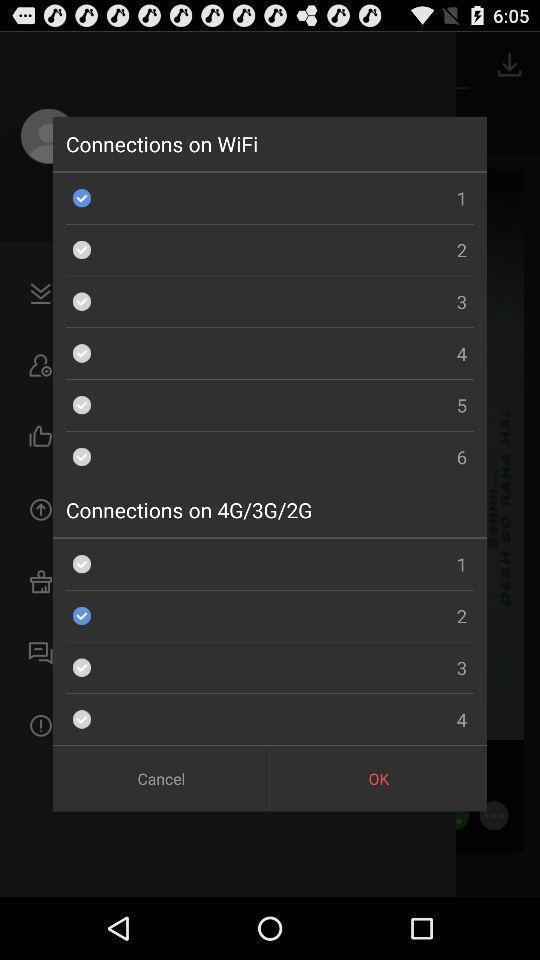What can you discern from this picture? Pop-up displaying different connections available. 